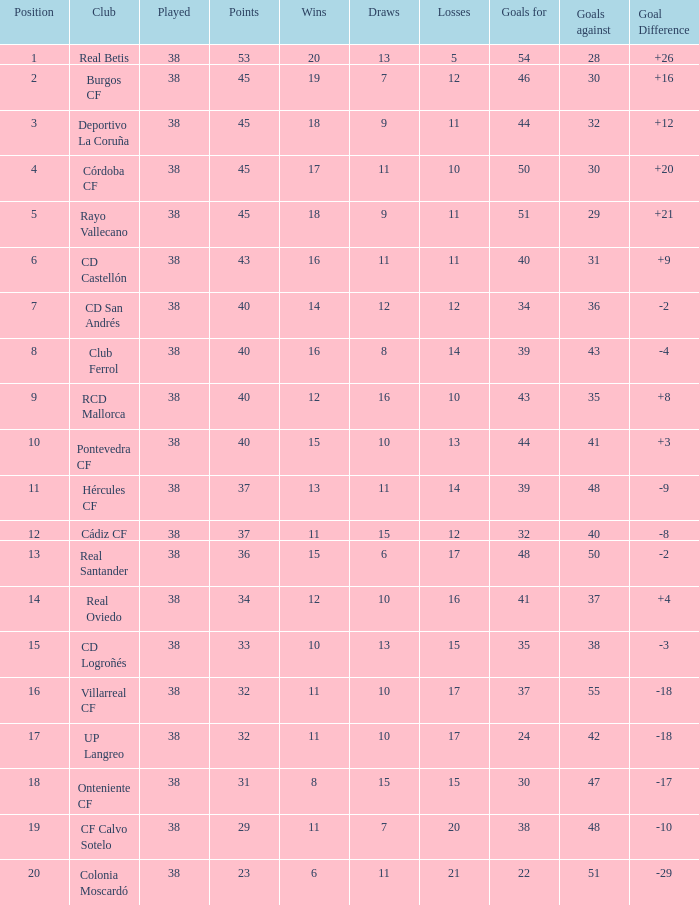In cases where the goal difference is higher than -3, goals against is 30, and points is above 45, what is the average number of draws? None. Give me the full table as a dictionary. {'header': ['Position', 'Club', 'Played', 'Points', 'Wins', 'Draws', 'Losses', 'Goals for', 'Goals against', 'Goal Difference'], 'rows': [['1', 'Real Betis', '38', '53', '20', '13', '5', '54', '28', '+26'], ['2', 'Burgos CF', '38', '45', '19', '7', '12', '46', '30', '+16'], ['3', 'Deportivo La Coruña', '38', '45', '18', '9', '11', '44', '32', '+12'], ['4', 'Córdoba CF', '38', '45', '17', '11', '10', '50', '30', '+20'], ['5', 'Rayo Vallecano', '38', '45', '18', '9', '11', '51', '29', '+21'], ['6', 'CD Castellón', '38', '43', '16', '11', '11', '40', '31', '+9'], ['7', 'CD San Andrés', '38', '40', '14', '12', '12', '34', '36', '-2'], ['8', 'Club Ferrol', '38', '40', '16', '8', '14', '39', '43', '-4'], ['9', 'RCD Mallorca', '38', '40', '12', '16', '10', '43', '35', '+8'], ['10', 'Pontevedra CF', '38', '40', '15', '10', '13', '44', '41', '+3'], ['11', 'Hércules CF', '38', '37', '13', '11', '14', '39', '48', '-9'], ['12', 'Cádiz CF', '38', '37', '11', '15', '12', '32', '40', '-8'], ['13', 'Real Santander', '38', '36', '15', '6', '17', '48', '50', '-2'], ['14', 'Real Oviedo', '38', '34', '12', '10', '16', '41', '37', '+4'], ['15', 'CD Logroñés', '38', '33', '10', '13', '15', '35', '38', '-3'], ['16', 'Villarreal CF', '38', '32', '11', '10', '17', '37', '55', '-18'], ['17', 'UP Langreo', '38', '32', '11', '10', '17', '24', '42', '-18'], ['18', 'Onteniente CF', '38', '31', '8', '15', '15', '30', '47', '-17'], ['19', 'CF Calvo Sotelo', '38', '29', '11', '7', '20', '38', '48', '-10'], ['20', 'Colonia Moscardó', '38', '23', '6', '11', '21', '22', '51', '-29']]} 